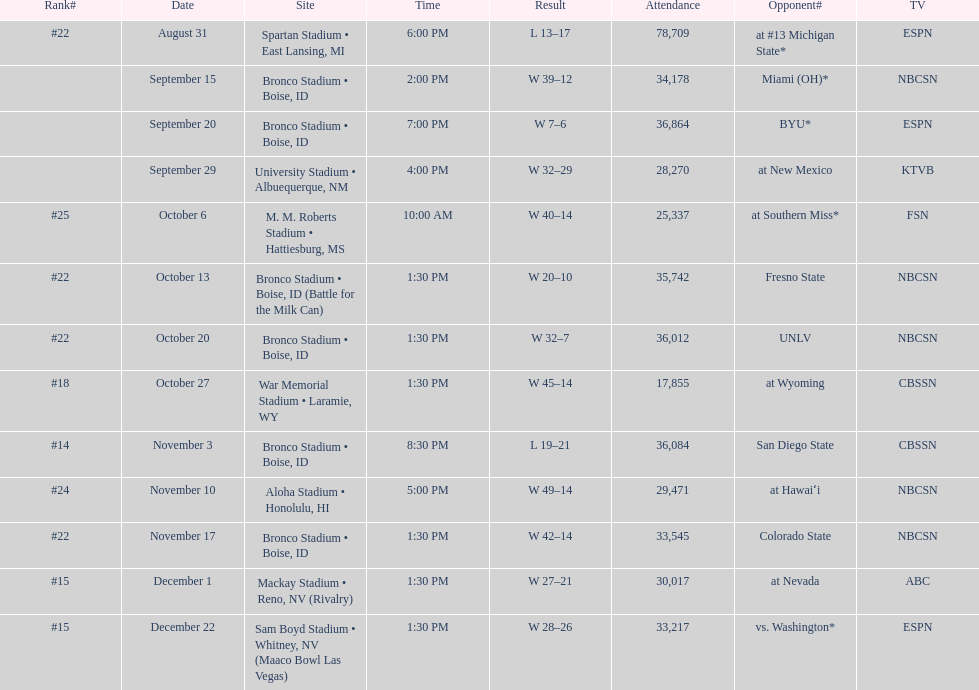What was the most consecutive wins for the team shown in the season? 7. 